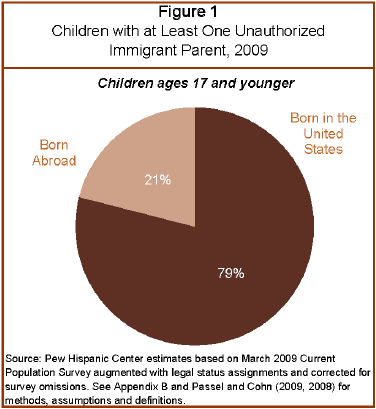Mention a couple of crucial points in this snapshot. According to recent data, approximately 79% of children are born in the United States. The radio of children born in the US and abroad is 3.7619. 